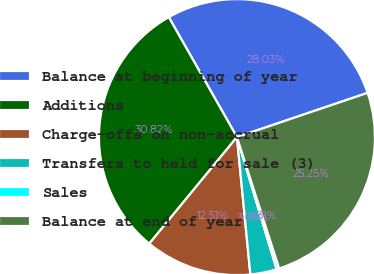<chart> <loc_0><loc_0><loc_500><loc_500><pie_chart><fcel>Balance at beginning of year<fcel>Additions<fcel>Charge-offs on non-accrual<fcel>Transfers to held for sale (3)<fcel>Sales<fcel>Balance at end of year<nl><fcel>28.03%<fcel>30.82%<fcel>12.51%<fcel>3.09%<fcel>0.31%<fcel>25.25%<nl></chart> 